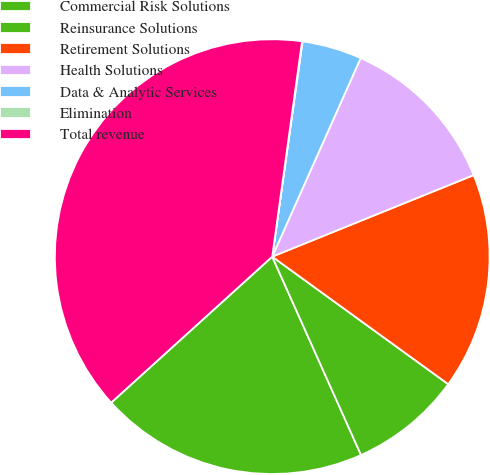Convert chart. <chart><loc_0><loc_0><loc_500><loc_500><pie_chart><fcel>Commercial Risk Solutions<fcel>Reinsurance Solutions<fcel>Retirement Solutions<fcel>Health Solutions<fcel>Data & Analytic Services<fcel>Elimination<fcel>Total revenue<nl><fcel>19.98%<fcel>8.32%<fcel>16.1%<fcel>12.21%<fcel>4.44%<fcel>0.04%<fcel>38.91%<nl></chart> 